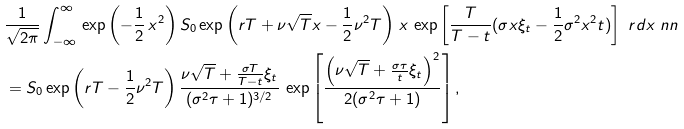<formula> <loc_0><loc_0><loc_500><loc_500>& \frac { 1 } { \sqrt { 2 \pi } } \int ^ { \infty } _ { - \infty } \, \exp \left ( - \frac { 1 } { 2 } \, x ^ { 2 } \right ) S _ { 0 } \exp \left ( r T + \nu \sqrt { T } x - \frac { 1 } { 2 } \nu ^ { 2 } T \right ) \, x \, \exp \left [ \frac { T } { T - t } ( \sigma x \xi _ { t } - \frac { 1 } { 2 } \sigma ^ { 2 } x ^ { 2 } t ) \right ] \ r d x \ n n \\ & = S _ { 0 } \exp \left ( r T - \frac { 1 } { 2 } \nu ^ { 2 } T \right ) \frac { \nu \sqrt { T } + \frac { \sigma T } { T - t } \xi _ { t } } { ( \sigma ^ { 2 } \tau + 1 ) ^ { 3 / 2 } } \, \exp \left [ \frac { \left ( \nu \sqrt { T } + \frac { \sigma \tau } { t } \xi _ { t } \right ) ^ { 2 } } { 2 ( \sigma ^ { 2 } \tau + 1 ) } \right ] ,</formula> 